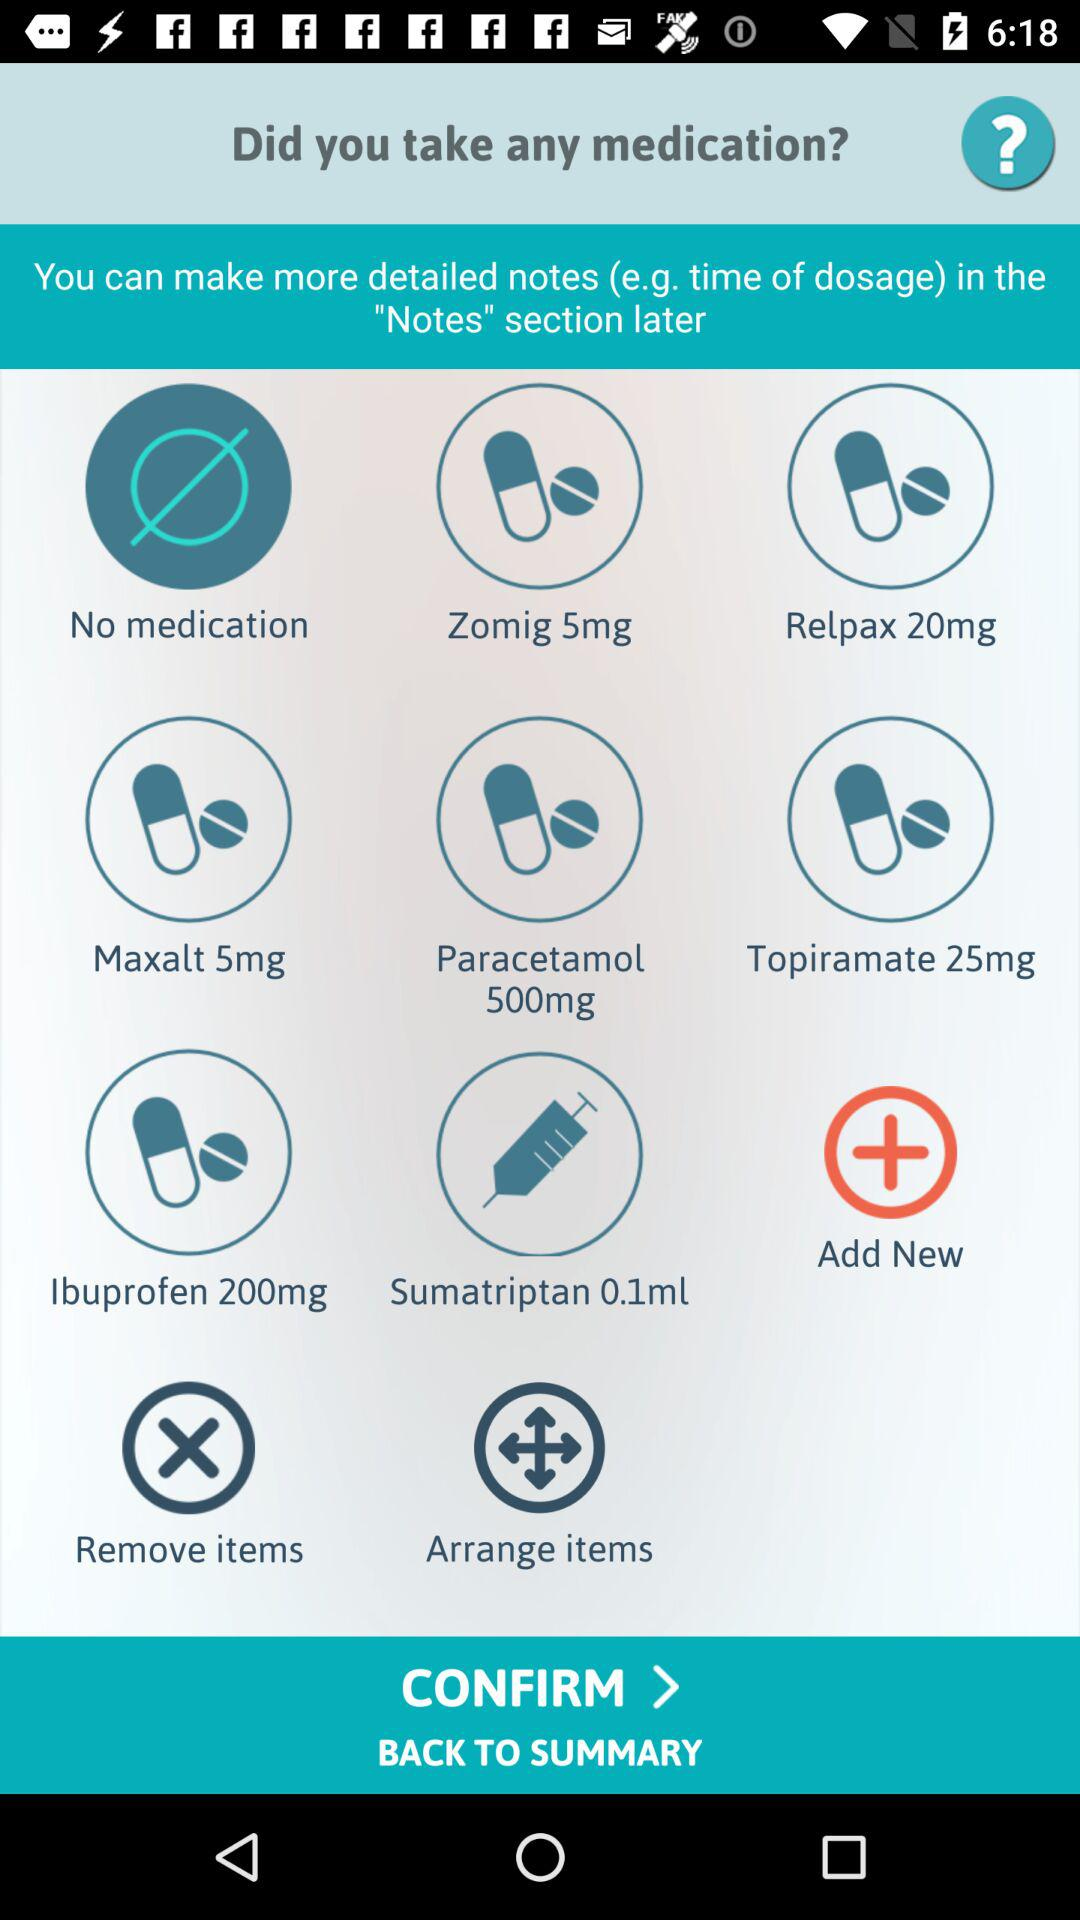Where can the detailed notes for the dosage be added? The detailed notes for the dosage can be added in the "Notes" section. 